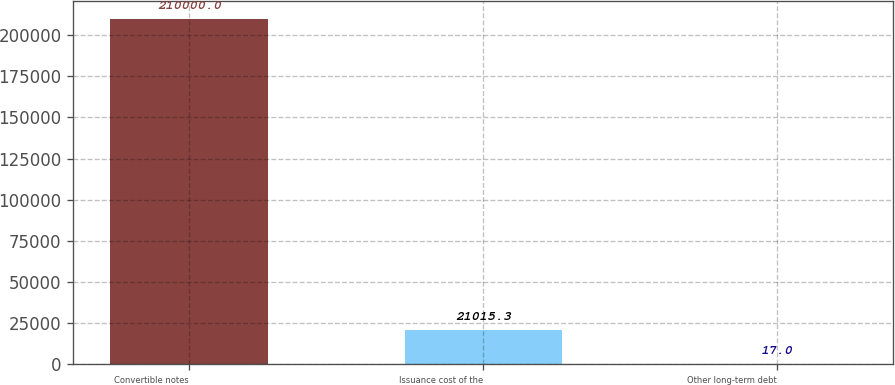Convert chart to OTSL. <chart><loc_0><loc_0><loc_500><loc_500><bar_chart><fcel>Convertible notes<fcel>Issuance cost of the<fcel>Other long-term debt<nl><fcel>210000<fcel>21015.3<fcel>17<nl></chart> 